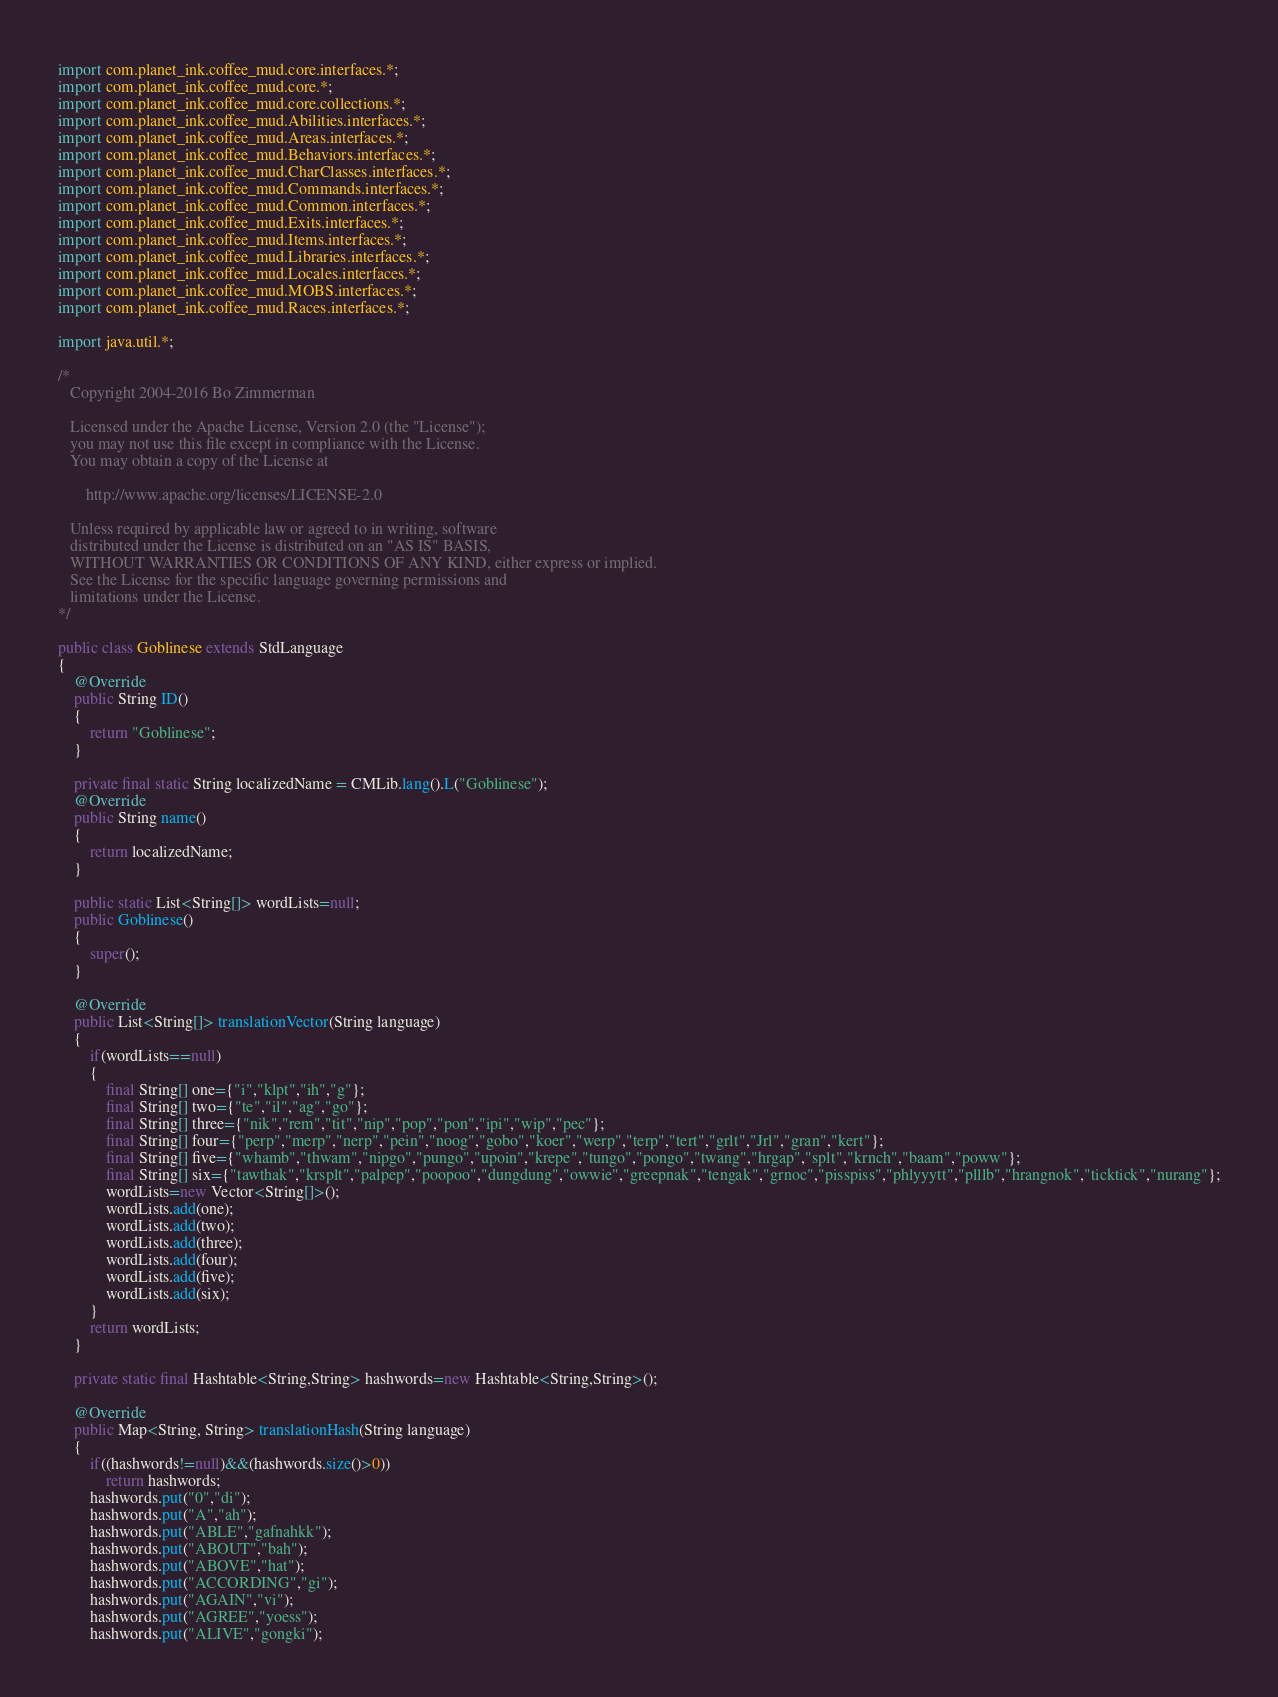<code> <loc_0><loc_0><loc_500><loc_500><_Java_>import com.planet_ink.coffee_mud.core.interfaces.*;
import com.planet_ink.coffee_mud.core.*;
import com.planet_ink.coffee_mud.core.collections.*;
import com.planet_ink.coffee_mud.Abilities.interfaces.*;
import com.planet_ink.coffee_mud.Areas.interfaces.*;
import com.planet_ink.coffee_mud.Behaviors.interfaces.*;
import com.planet_ink.coffee_mud.CharClasses.interfaces.*;
import com.planet_ink.coffee_mud.Commands.interfaces.*;
import com.planet_ink.coffee_mud.Common.interfaces.*;
import com.planet_ink.coffee_mud.Exits.interfaces.*;
import com.planet_ink.coffee_mud.Items.interfaces.*;
import com.planet_ink.coffee_mud.Libraries.interfaces.*;
import com.planet_ink.coffee_mud.Locales.interfaces.*;
import com.planet_ink.coffee_mud.MOBS.interfaces.*;
import com.planet_ink.coffee_mud.Races.interfaces.*;

import java.util.*;

/*
   Copyright 2004-2016 Bo Zimmerman

   Licensed under the Apache License, Version 2.0 (the "License");
   you may not use this file except in compliance with the License.
   You may obtain a copy of the License at

	   http://www.apache.org/licenses/LICENSE-2.0

   Unless required by applicable law or agreed to in writing, software
   distributed under the License is distributed on an "AS IS" BASIS,
   WITHOUT WARRANTIES OR CONDITIONS OF ANY KIND, either express or implied.
   See the License for the specific language governing permissions and
   limitations under the License.
*/

public class Goblinese extends StdLanguage
{
	@Override
	public String ID()
	{
		return "Goblinese";
	}

	private final static String localizedName = CMLib.lang().L("Goblinese");
	@Override
	public String name()
	{
		return localizedName;
	}

	public static List<String[]> wordLists=null;
	public Goblinese()
	{
		super();
	}

	@Override
	public List<String[]> translationVector(String language)
	{
		if(wordLists==null)
		{
			final String[] one={"i","klpt","ih","g"};
			final String[] two={"te","il","ag","go"};
			final String[] three={"nik","rem","tit","nip","pop","pon","ipi","wip","pec"};
			final String[] four={"perp","merp","nerp","pein","noog","gobo","koer","werp","terp","tert","grlt","Jrl","gran","kert"};
			final String[] five={"whamb","thwam","nipgo","pungo","upoin","krepe","tungo","pongo","twang","hrgap","splt","krnch","baam","poww"};
			final String[] six={"tawthak","krsplt","palpep","poopoo","dungdung","owwie","greepnak","tengak","grnoc","pisspiss","phlyyytt","plllb","hrangnok","ticktick","nurang"};
			wordLists=new Vector<String[]>();
			wordLists.add(one);
			wordLists.add(two);
			wordLists.add(three);
			wordLists.add(four);
			wordLists.add(five);
			wordLists.add(six);
		}
		return wordLists;
	}

	private static final Hashtable<String,String> hashwords=new Hashtable<String,String>();
	
	@Override
	public Map<String, String> translationHash(String language)
	{
		if((hashwords!=null)&&(hashwords.size()>0))
			return hashwords;
		hashwords.put("0","di");
		hashwords.put("A","ah");
		hashwords.put("ABLE","gafnahkk");
		hashwords.put("ABOUT","bah");
		hashwords.put("ABOVE","hat");
		hashwords.put("ACCORDING","gi");
		hashwords.put("AGAIN","vi");
		hashwords.put("AGREE","yoess");
		hashwords.put("ALIVE","gongki");</code> 